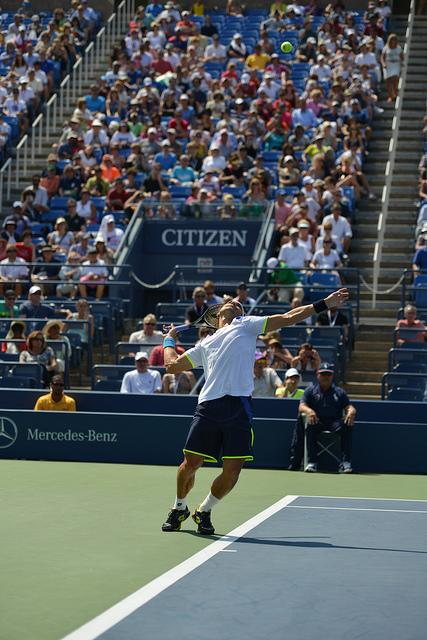What type action is the tennis player here doing?

Choices:
A) judging
B) return
C) serving
D) resting serving 